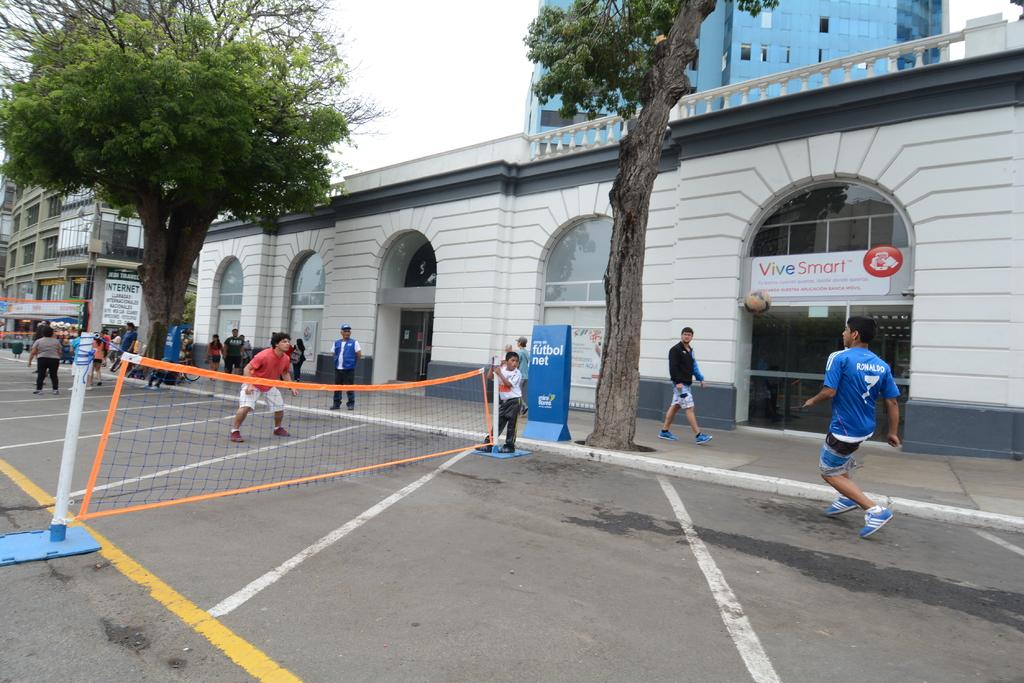What are the people in the image doing? The people in the image are standing on the ground. What object is present in the image that is typically used for separating or dividing? There is a net in the image. What type of structures can be seen in the image? There are buildings in the image. What type of vegetation is visible in the image? There are trees in the image. What is visible in the background of the image? The sky is visible in the background of the image. What type of soup is being served in the image? There is no soup present in the image. What type of animal can be seen interacting with the people in the image? There are no animals visible in the image; only people, a net, buildings, trees, and the sky are present. 